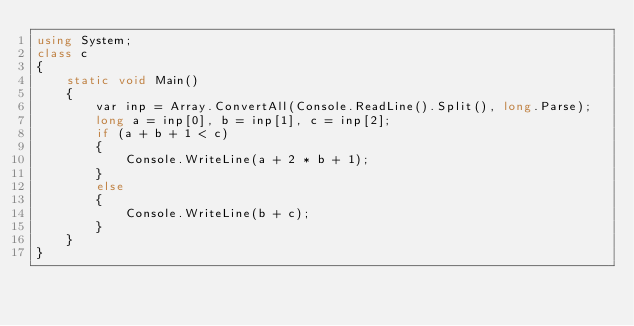Convert code to text. <code><loc_0><loc_0><loc_500><loc_500><_C#_>using System;
class c
{
    static void Main()
    {
        var inp = Array.ConvertAll(Console.ReadLine().Split(), long.Parse);
        long a = inp[0], b = inp[1], c = inp[2];
        if (a + b + 1 < c)
        {
            Console.WriteLine(a + 2 * b + 1);
        }
        else
        {
            Console.WriteLine(b + c);
        }
    }
}</code> 